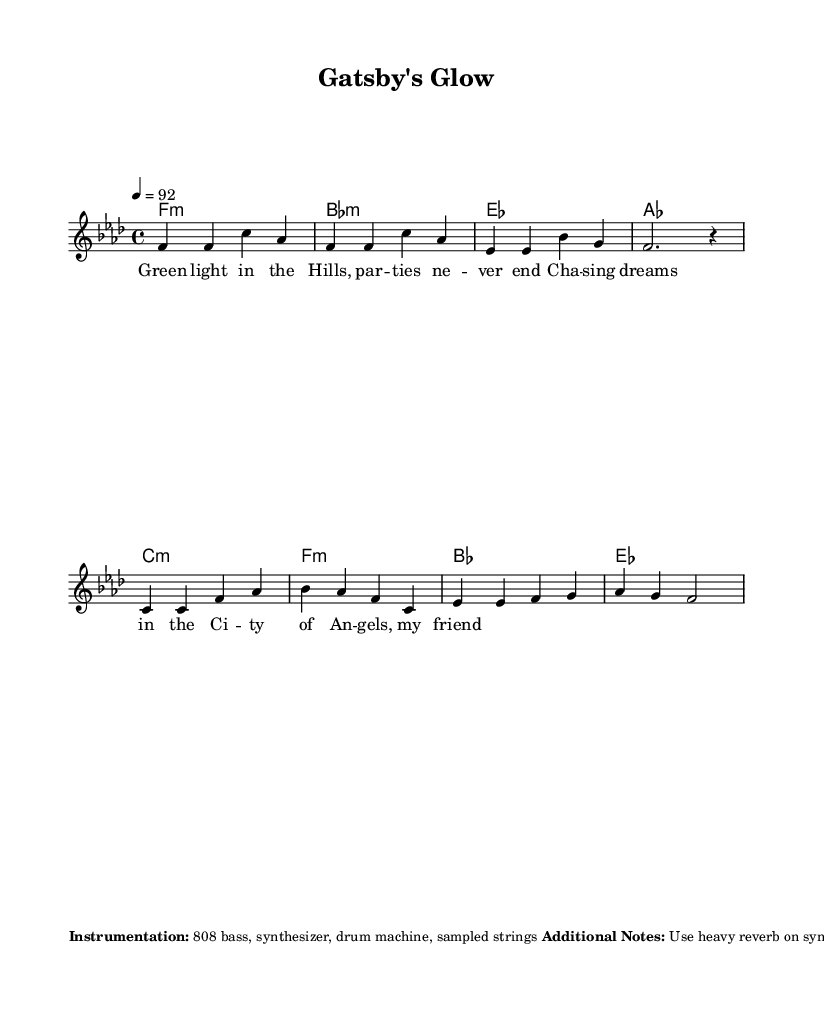What is the key signature of this music? The key signature is indicated at the beginning of the score. In this case, it shows four flats, indicating that it is in F minor.
Answer: F minor What is the time signature of this music? The time signature is shown right after the key signature. It is written as 4/4, which means there are four beats in each measure and a quarter note receives one beat.
Answer: 4/4 What is the tempo marking for this piece? The tempo marking is found below the time signature, indicated as "4 = 92". This means that the quarter note is set to a tempo of 92 beats per minute.
Answer: 92 How many measures are present in the main hook? By counting the number of distinct groups separated by the bar lines in the main hook section, there are four measures.
Answer: 4 What type of instrumentation is suggested for this piece? The instrumentation is specifically listed in the markup section at the end of the score, detailing the instruments that should be used. The score mentions "808 bass, synthesizer, drum machine, sampled strings."
Answer: 808 bass, synthesizer, drum machine, sampled strings What is the overall theme reflected in the lyrics of this piece? The lyrics reference specific imagery and emotions that connect to dreams and aspirations, particularly tied to the iconic green light from "The Great Gatsby", suggesting a thematic connection to ambition and the pursuit of dreams in an urban environment.
Answer: Ambition and dreams How does the time signature influence the style of this hip-hop piece? The 4/4 time signature is standard in hip-hop music, allowing for a steady rhythm and predictable beat that is conducive to rapping and lyrical flow. This structure complements the genre's emphasis on rhythm and rhyme.
Answer: Standard hip-hop structure 